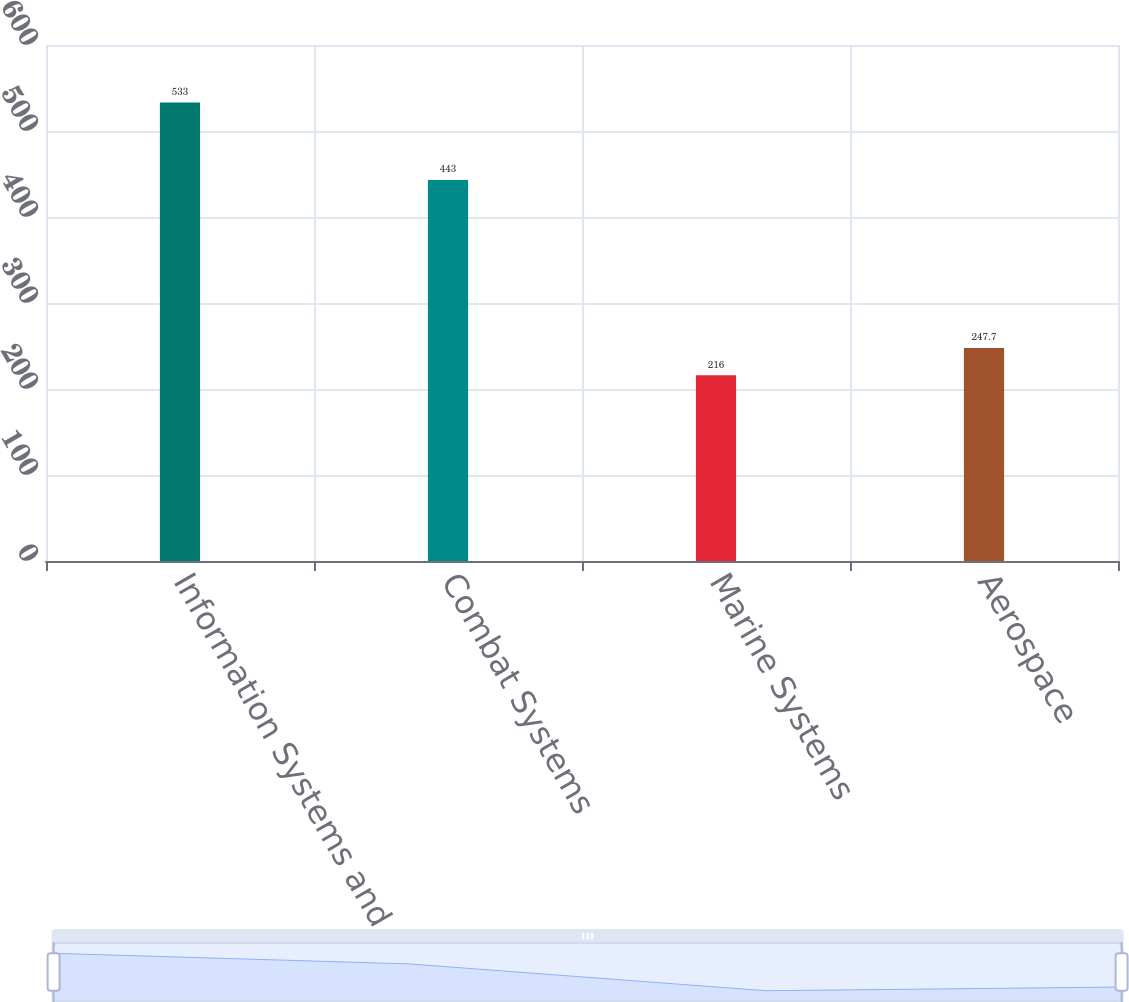<chart> <loc_0><loc_0><loc_500><loc_500><bar_chart><fcel>Information Systems and<fcel>Combat Systems<fcel>Marine Systems<fcel>Aerospace<nl><fcel>533<fcel>443<fcel>216<fcel>247.7<nl></chart> 